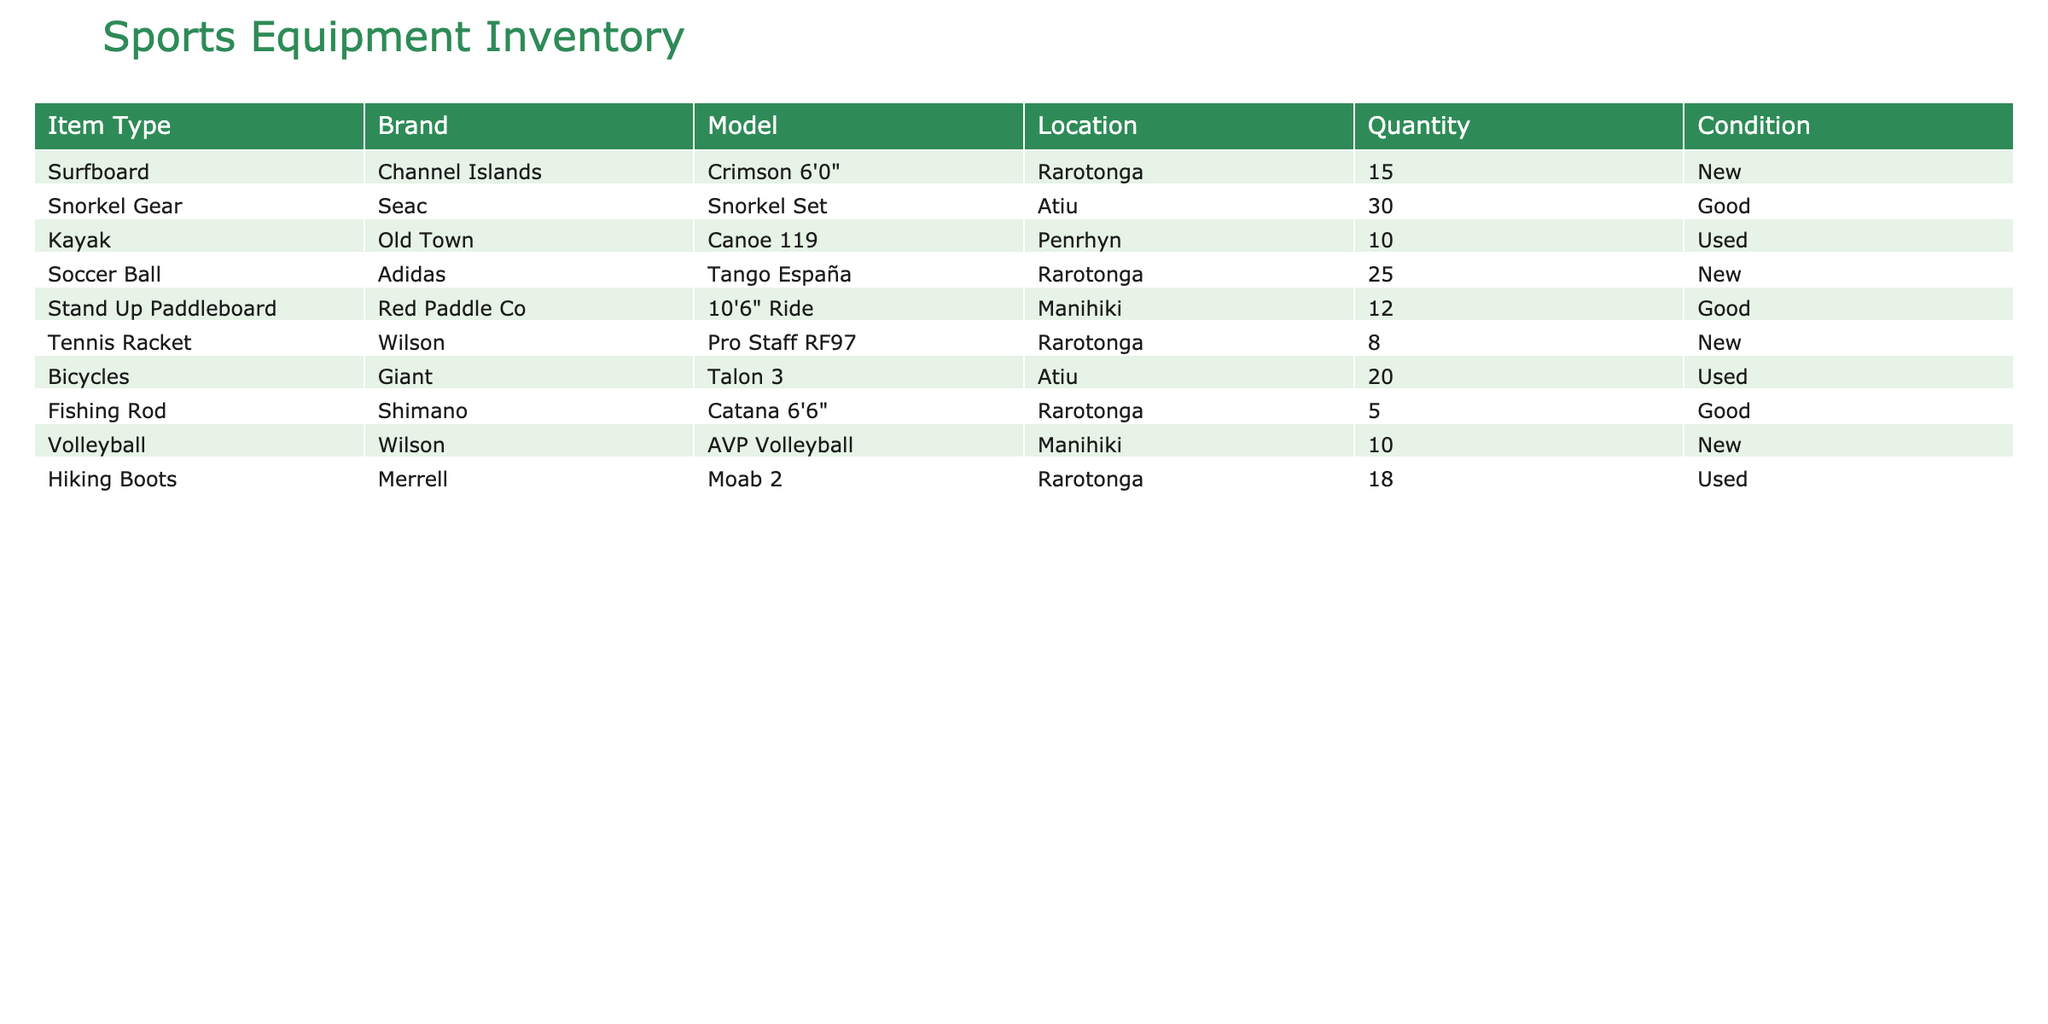What is the total quantity of Surfboards available in Rarotonga? The table shows that there are 15 Surfboards listed under the Location Rarotonga. Therefore, the total quantity for Surfboards in that location is simply the value listed in the Quantity column.
Answer: 15 How many unique brands of sports equipment are there in the inventory? By examining the Brand column, we can identify the distinct brands available: Channel Islands, Seac, Old Town, Adidas, Red Paddle Co, Wilson, Giant, and Shimano. This gives us a total of 8 unique brands.
Answer: 8 Which item type has the highest quantity in the inventory? Looking at the Quantity column, we observe the following maximum values: Surfboards have 15, Snorkel Gear has 30, Kayaks have 10, Soccer Balls have 25, Stand Up Paddleboards have 12, Tennis Rackets have 8, Bicycles have 20, Fishing Rods have 5, Volleyballs have 10, and Hiking Boots have 18. The highest quantity is for Snorkel Gear with 30.
Answer: Snorkel Gear Are there any items under the "New" condition that have a quantity of less than 10? Reviewing the Condition and Quantity columns, we check the items marked as "New." The items are Surfboards (15), Soccer Balls (25), and Tennis Rackets (8). The only item in this category with a quantity less than 10 is the Tennis Racket.
Answer: Yes What is the average quantity of Sport equipment across all types in the Rarotonga location? To find the average quantity, first identify the items located in Rarotonga: Surfboards (15), Soccer Balls (25), Tennis Rackets (8), and Fishing Rods (5). Now we sum these quantities: 15 + 25 + 8 + 5 = 53. Since there are 4 items, we calculate the average as 53 / 4 = 13.25.
Answer: 13.25 How many items are in "Good" condition at the Manihiki location? Checking both the Condition and Location columns for Manihiki, we see that there is a Stand Up Paddleboard (12) and a Volleyball (10) listed under "Good" condition. Therefore, we total these quantities: 12 + 10 = 22.
Answer: 22 Is there more soccer equipment in Rarotonga than in Atiu? In Rarotonga, there are Soccer Balls which total 25, while in Atiu there is no soccer equipment listed. Therefore, comparing the two quantities shows that Rarotonga has significantly more soccer equipment than Atiu.
Answer: Yes What percentage of total equipment is composed of bicycles? The total quantity of all items is calculated first: 15 (Surfboards) + 30 (Snorkel Gear) + 10 (Kayaks) + 25 (Soccer Balls) + 12 (Stand Up Paddleboards) + 8 (Tennis Rackets) + 20 (Bicycles) + 5 (Fishing Rods) + 10 (Volleyballs) + 18 (Hiking Boots) =  143. The number of Bicycles is 20, so the percentage is calculated as (20 / 143) * 100 = 13.99%.
Answer: 13.99% 